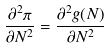<formula> <loc_0><loc_0><loc_500><loc_500>\frac { \partial ^ { 2 } \pi } { \partial N ^ { 2 } } = \frac { \partial ^ { 2 } g ( N ) } { \partial N ^ { 2 } }</formula> 